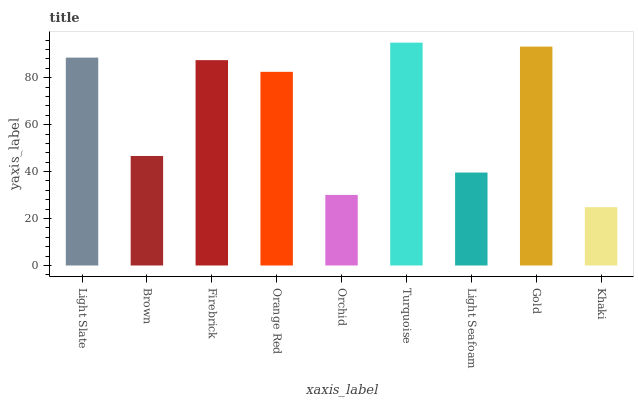Is Brown the minimum?
Answer yes or no. No. Is Brown the maximum?
Answer yes or no. No. Is Light Slate greater than Brown?
Answer yes or no. Yes. Is Brown less than Light Slate?
Answer yes or no. Yes. Is Brown greater than Light Slate?
Answer yes or no. No. Is Light Slate less than Brown?
Answer yes or no. No. Is Orange Red the high median?
Answer yes or no. Yes. Is Orange Red the low median?
Answer yes or no. Yes. Is Firebrick the high median?
Answer yes or no. No. Is Gold the low median?
Answer yes or no. No. 